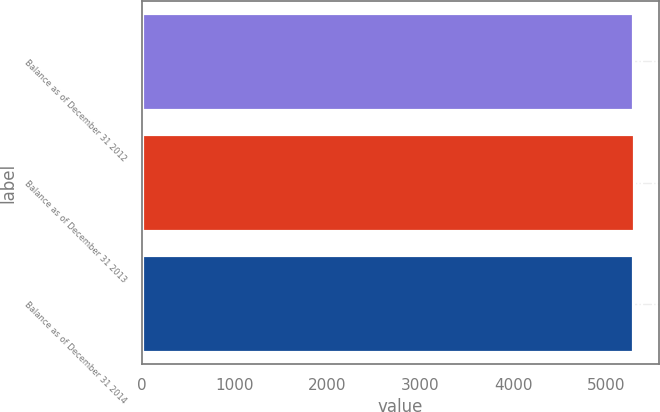Convert chart. <chart><loc_0><loc_0><loc_500><loc_500><bar_chart><fcel>Balance as of December 31 2012<fcel>Balance as of December 31 2013<fcel>Balance as of December 31 2014<nl><fcel>5287<fcel>5294<fcel>5286<nl></chart> 